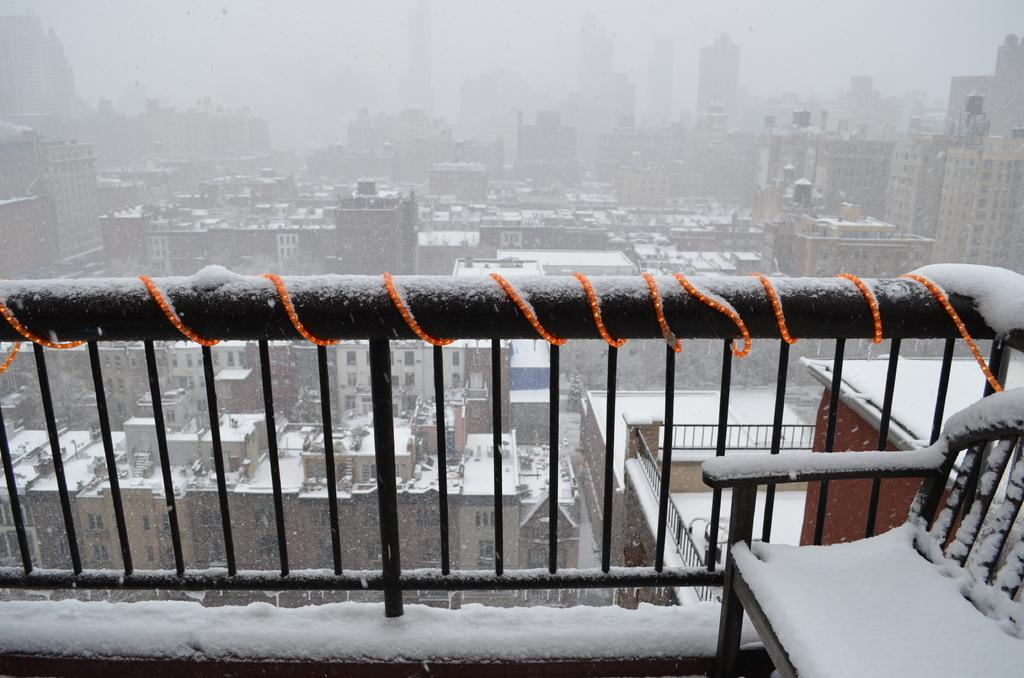What is covering the iron grill in the image? There is snow on the iron grill. What piece of furniture can be seen in the image? There is a chair in the image. What can be seen in the distance behind the chair? There are buildings visible in the background. How is the snow affecting the buildings in the image? The buildings have snow on them. What type of brass instrument is being played in the image? There is no brass instrument or any indication of music being played in the image. Can you describe the flight of the birds in the image? There are no birds present in the image, so it is not possible to describe their flight. 